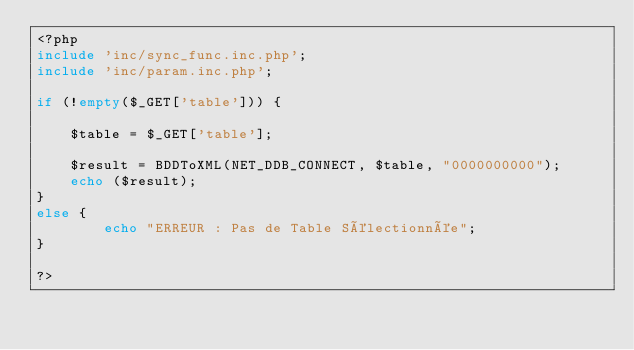Convert code to text. <code><loc_0><loc_0><loc_500><loc_500><_PHP_><?php
include 'inc/sync_func.inc.php';
include 'inc/param.inc.php';

if (!empty($_GET['table'])) {
	
	$table = $_GET['table'];

	$result = BDDToXML(NET_DDB_CONNECT, $table, "0000000000");
	echo ($result);
}
else {
		echo "ERREUR : Pas de Table Sélectionnée";
}

?>
</code> 